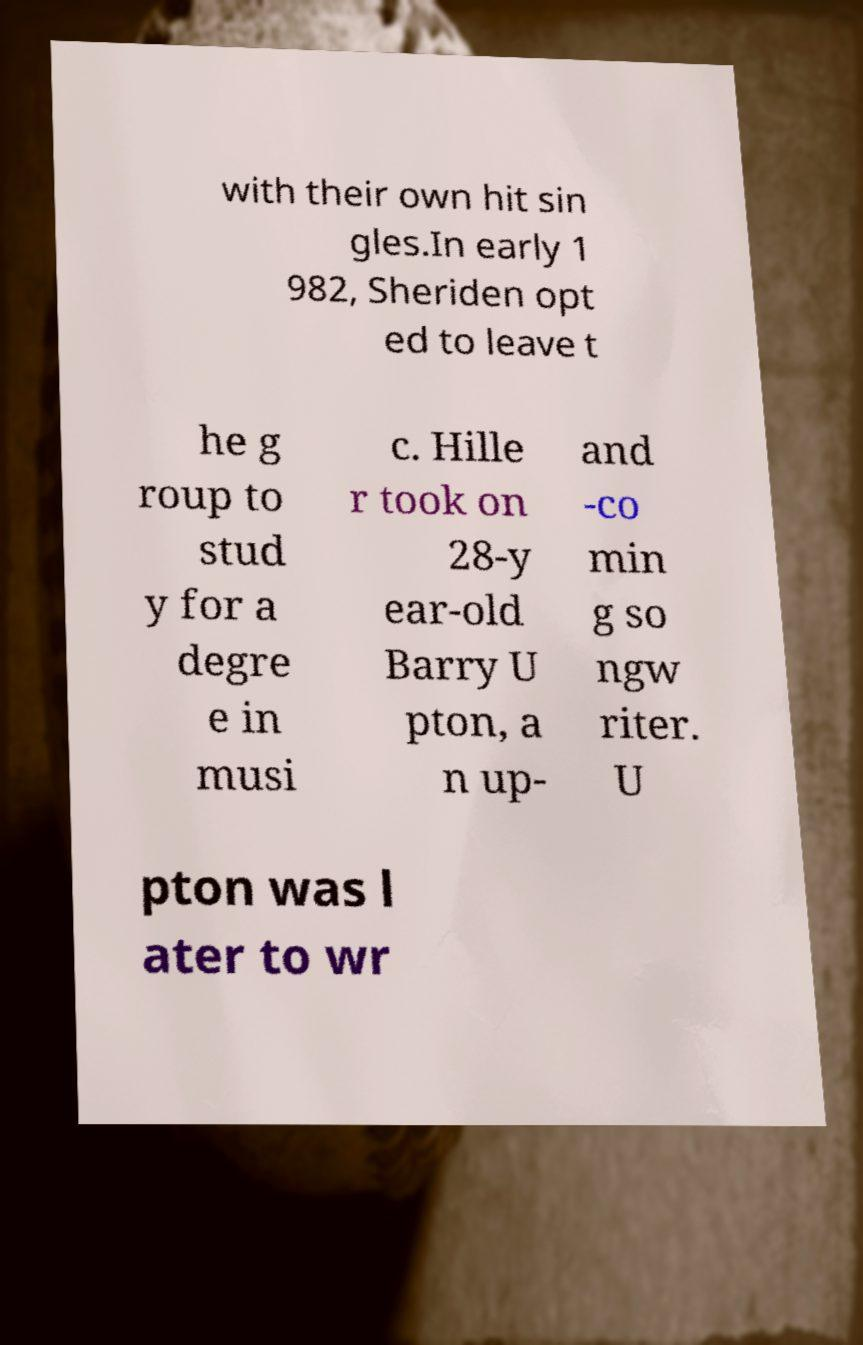Could you assist in decoding the text presented in this image and type it out clearly? with their own hit sin gles.In early 1 982, Sheriden opt ed to leave t he g roup to stud y for a degre e in musi c. Hille r took on 28-y ear-old Barry U pton, a n up- and -co min g so ngw riter. U pton was l ater to wr 